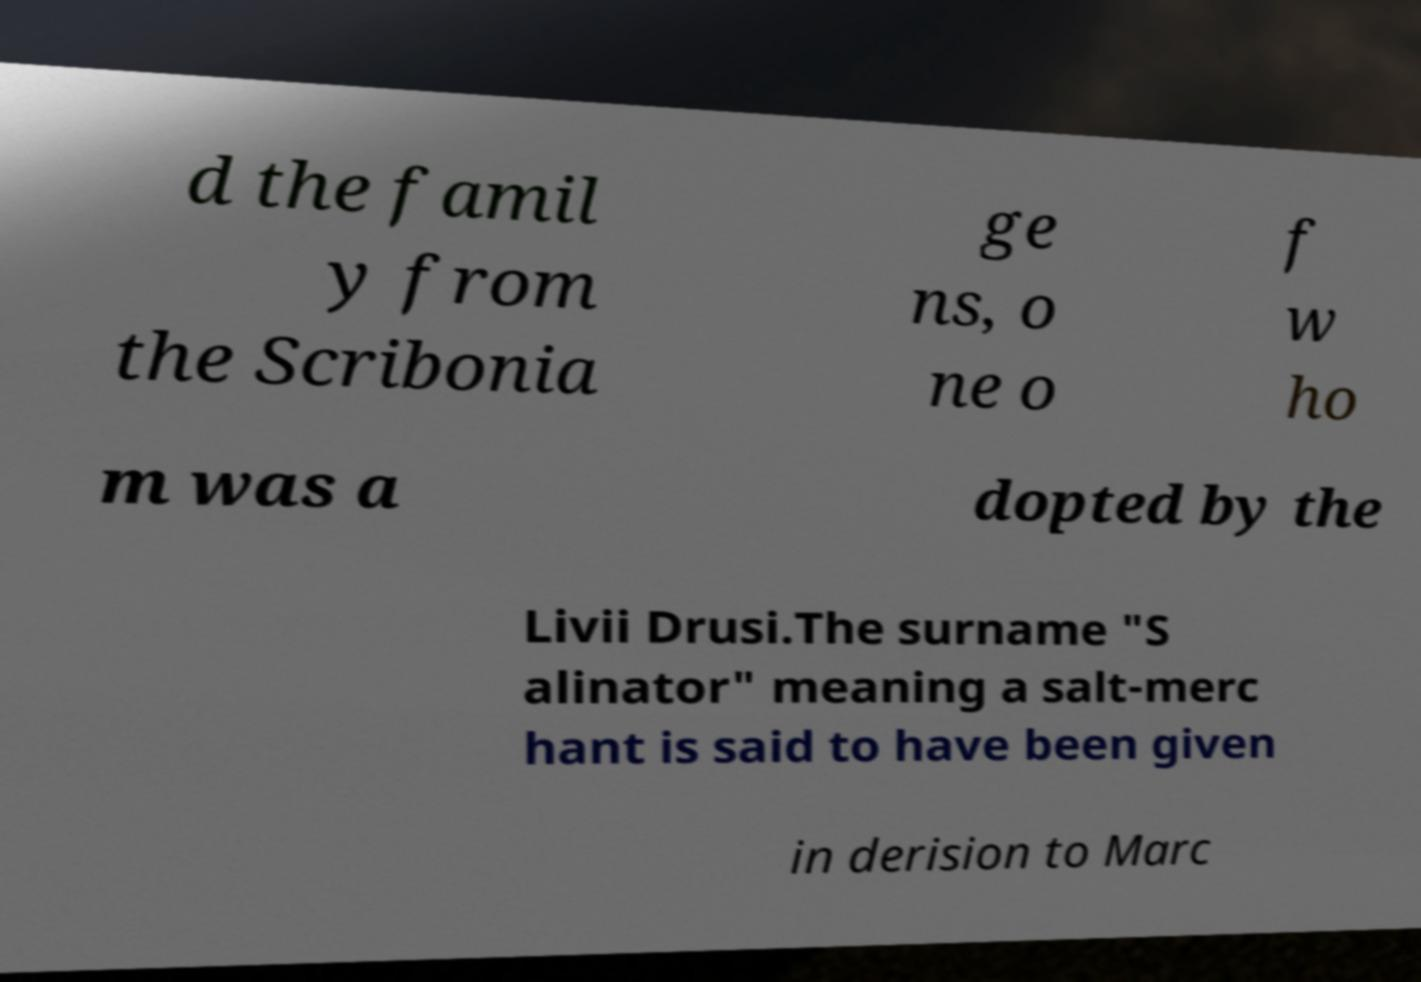Can you accurately transcribe the text from the provided image for me? d the famil y from the Scribonia ge ns, o ne o f w ho m was a dopted by the Livii Drusi.The surname "S alinator" meaning a salt-merc hant is said to have been given in derision to Marc 